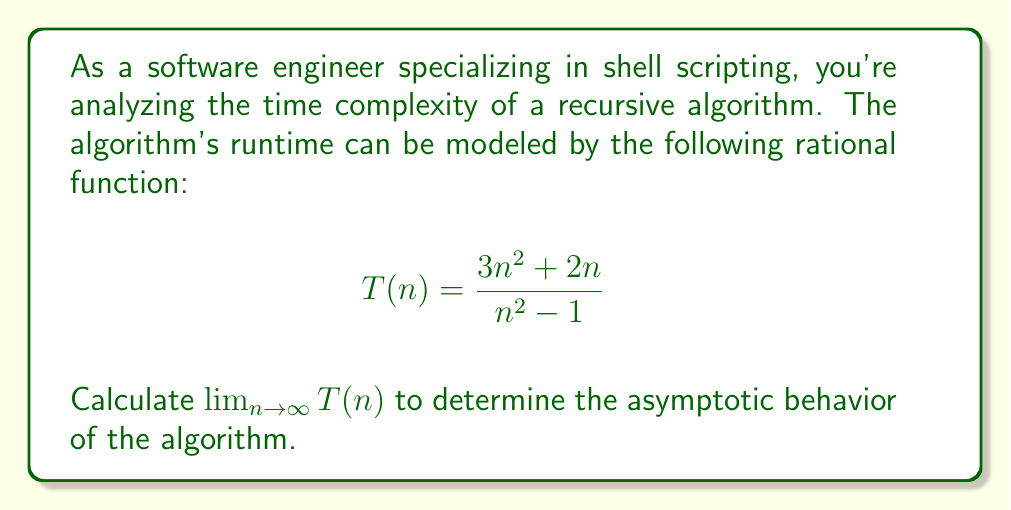Can you solve this math problem? To find the limit of this rational function as n approaches infinity, we'll follow these steps:

1) First, let's examine the degrees of the numerator and denominator:
   Numerator: $3n^2 + 2n$ (degree 2)
   Denominator: $n^2 - 1$ (degree 2)

2) When the degrees are equal, we can find the limit by comparing the leading coefficients:

   $$\lim_{n \to \infty} T(n) = \lim_{n \to \infty} \frac{3n^2 + 2n}{n^2 - 1}$$

3) Divide both numerator and denominator by the highest power of n (n^2):

   $$\lim_{n \to \infty} \frac{3n^2 + 2n}{n^2 - 1} = \lim_{n \to \infty} \frac{3 + \frac{2}{n}}{1 - \frac{1}{n^2}}$$

4) As n approaches infinity, $\frac{2}{n}$ and $\frac{1}{n^2}$ approach 0:

   $$\lim_{n \to \infty} \frac{3 + \frac{2}{n}}{1 - \frac{1}{n^2}} = \frac{3 + 0}{1 - 0} = 3$$

Therefore, the limit of T(n) as n approaches infinity is 3.

In terms of algorithmic complexity, this means that for very large inputs, the algorithm's runtime approaches a constant multiple of n^2, indicating O(n^2) time complexity.
Answer: 3 